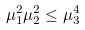<formula> <loc_0><loc_0><loc_500><loc_500>\mu _ { 1 } ^ { 2 } \mu _ { 2 } ^ { 2 } \leq \mu _ { 3 } ^ { 4 }</formula> 